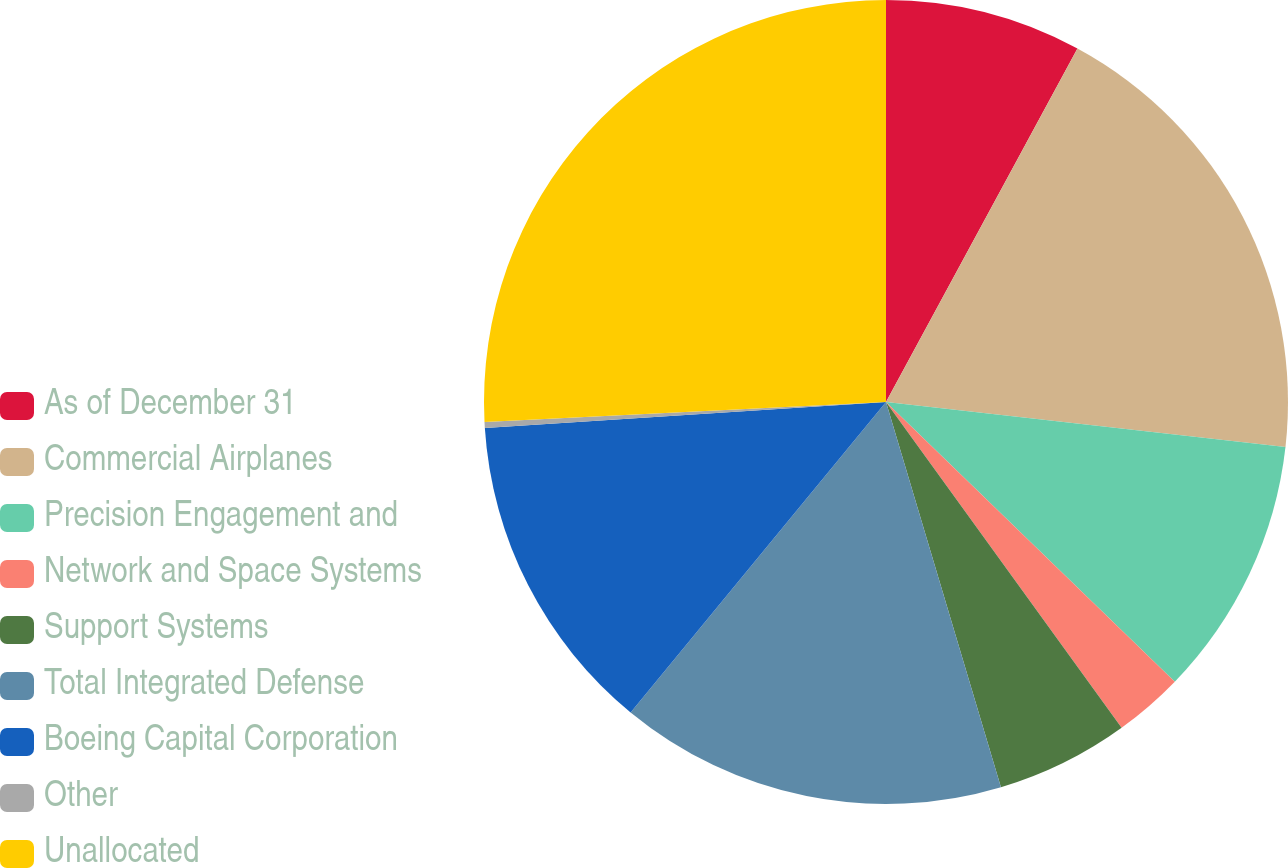<chart> <loc_0><loc_0><loc_500><loc_500><pie_chart><fcel>As of December 31<fcel>Commercial Airplanes<fcel>Precision Engagement and<fcel>Network and Space Systems<fcel>Support Systems<fcel>Total Integrated Defense<fcel>Boeing Capital Corporation<fcel>Other<fcel>Unallocated<nl><fcel>7.9%<fcel>18.88%<fcel>10.46%<fcel>2.79%<fcel>5.35%<fcel>15.57%<fcel>13.01%<fcel>0.24%<fcel>25.79%<nl></chart> 